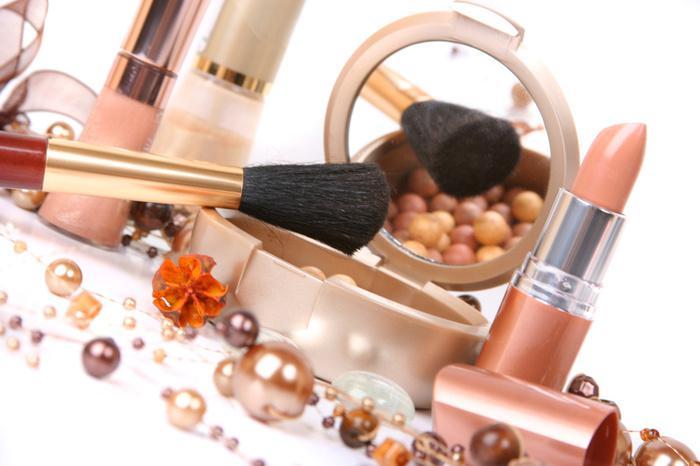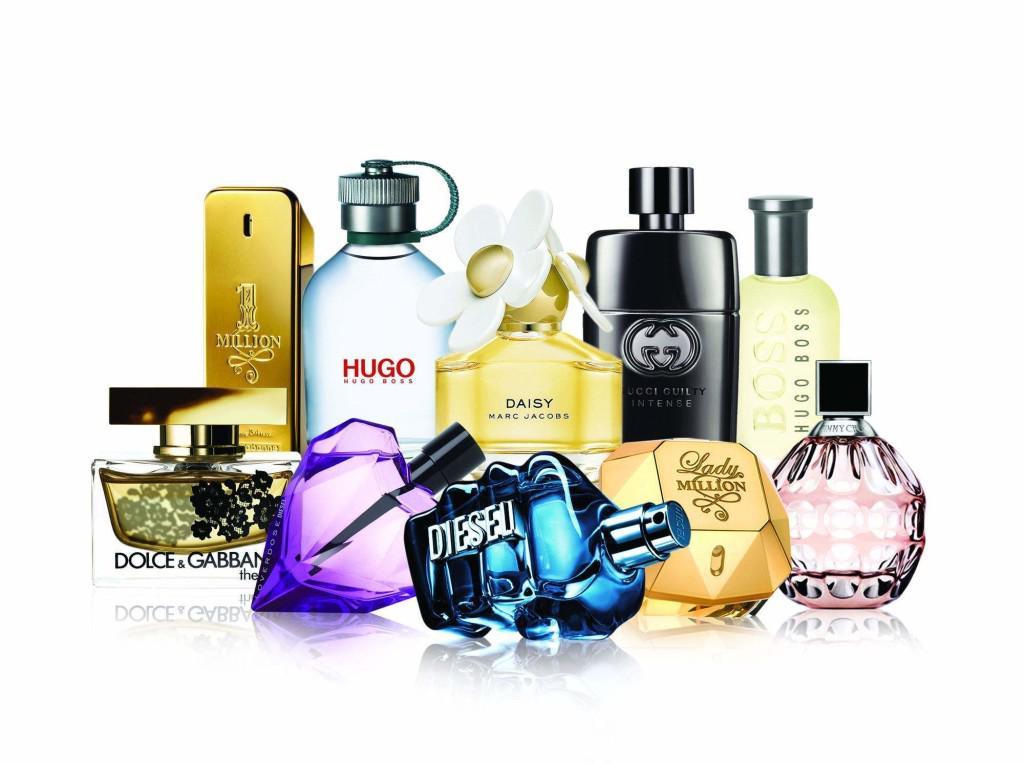The first image is the image on the left, the second image is the image on the right. Assess this claim about the two images: "The left image features a horizontal row of at least five different fragrance bottle shapes, while the right image shows at least one bottle in front of its box.". Correct or not? Answer yes or no. No. The first image is the image on the left, the second image is the image on the right. For the images displayed, is the sentence "There are six bottles grouped together in the image on the left." factually correct? Answer yes or no. No. 